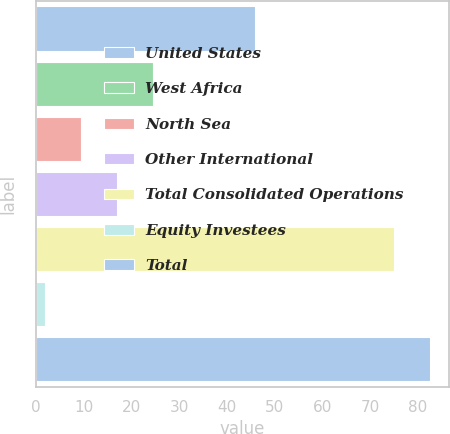Convert chart to OTSL. <chart><loc_0><loc_0><loc_500><loc_500><bar_chart><fcel>United States<fcel>West Africa<fcel>North Sea<fcel>Other International<fcel>Total Consolidated Operations<fcel>Equity Investees<fcel>Total<nl><fcel>46<fcel>24.5<fcel>9.5<fcel>17<fcel>75<fcel>2<fcel>82.5<nl></chart> 